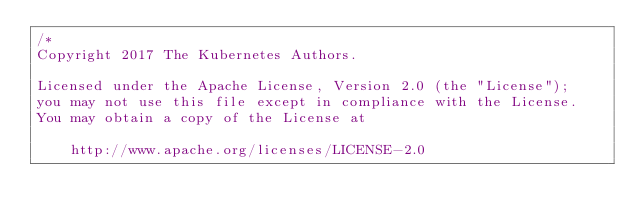Convert code to text. <code><loc_0><loc_0><loc_500><loc_500><_Go_>/*
Copyright 2017 The Kubernetes Authors.

Licensed under the Apache License, Version 2.0 (the "License");
you may not use this file except in compliance with the License.
You may obtain a copy of the License at

    http://www.apache.org/licenses/LICENSE-2.0
</code> 